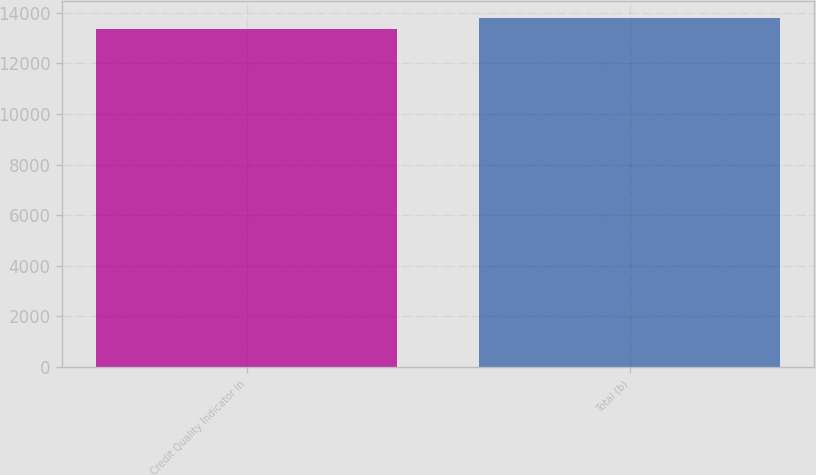Convert chart. <chart><loc_0><loc_0><loc_500><loc_500><bar_chart><fcel>Credit Quality Indicator In<fcel>Total (b)<nl><fcel>13365<fcel>13788<nl></chart> 